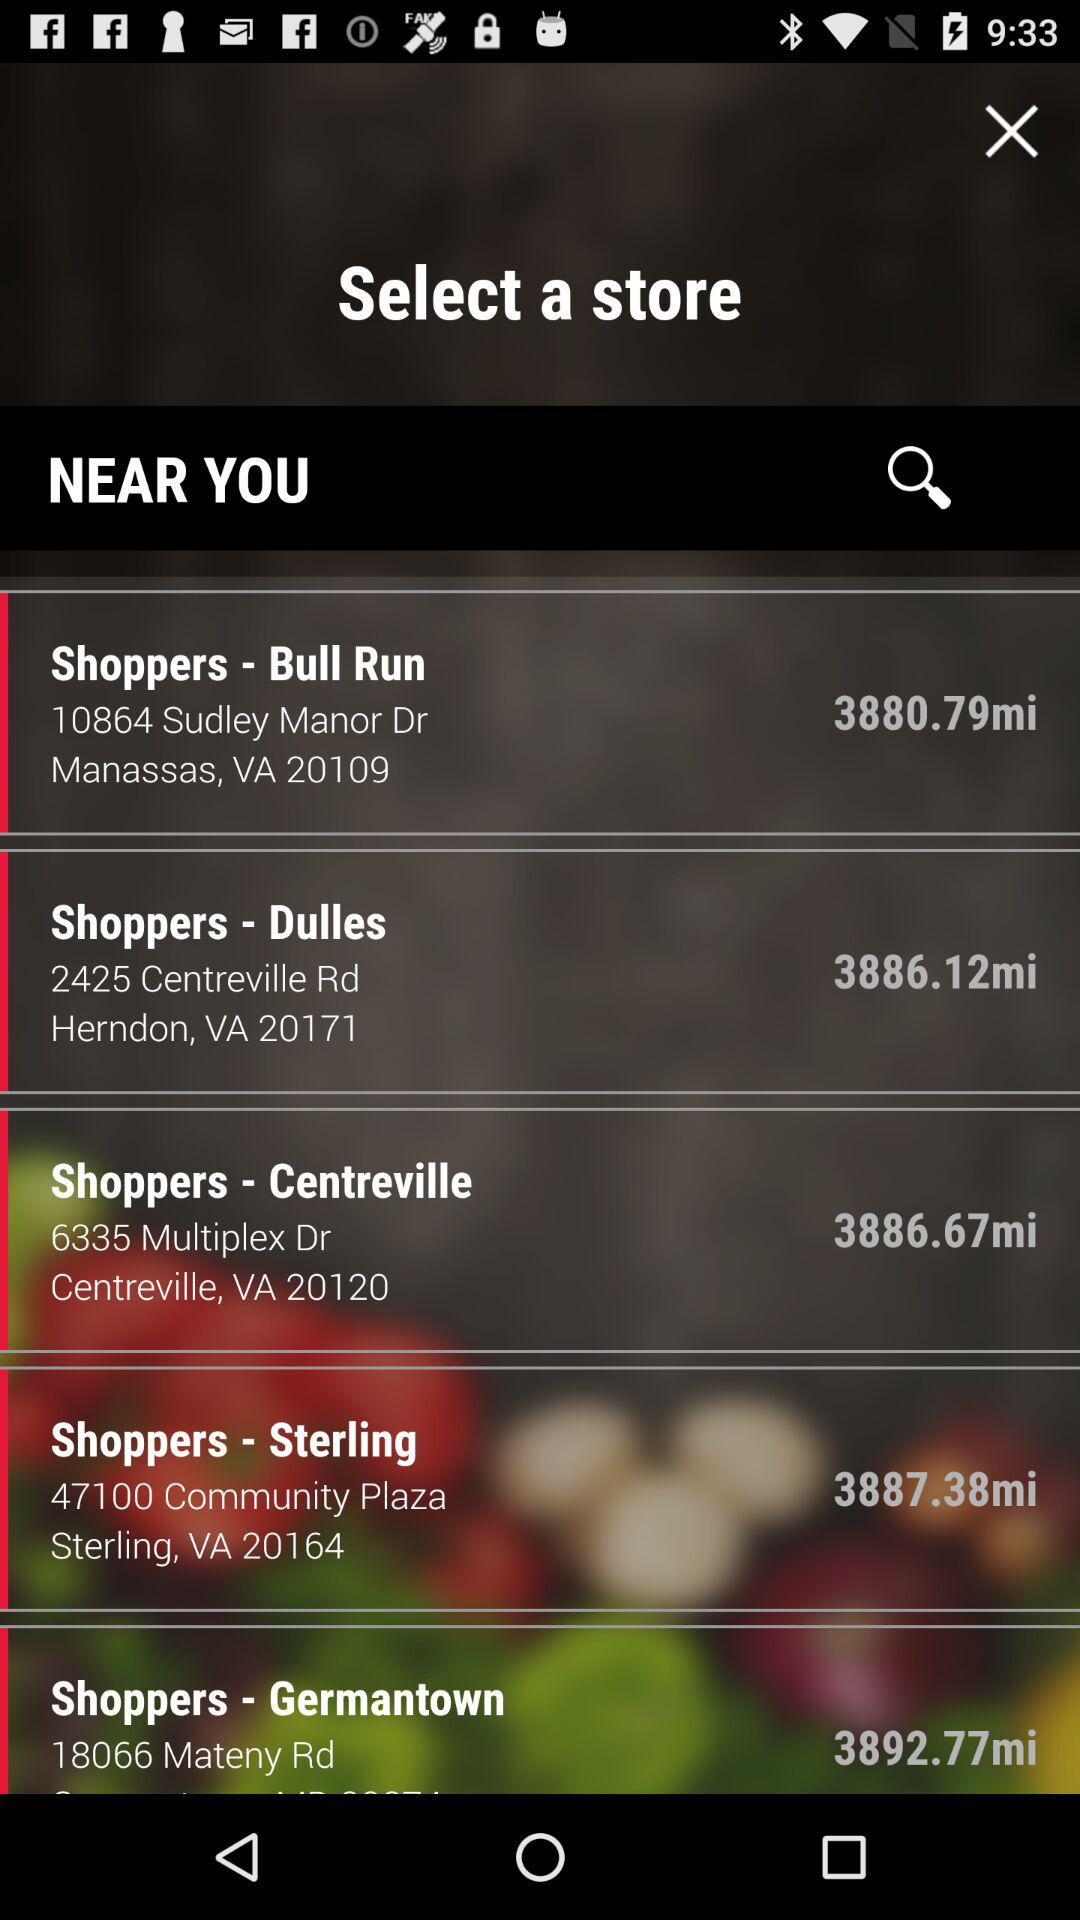How far is "Shoppers" situated in Centreville? It is 3886.67 miles away. 